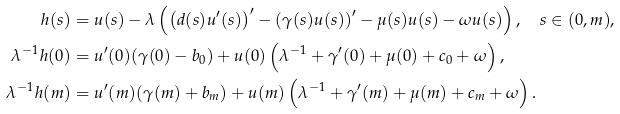Convert formula to latex. <formula><loc_0><loc_0><loc_500><loc_500>h ( s ) & = u ( s ) - \lambda \left ( \left ( d ( s ) u ^ { \prime } ( s ) \right ) ^ { \prime } - \left ( \gamma ( s ) u ( s ) \right ) ^ { \prime } - \mu ( s ) u ( s ) - \omega u ( s ) \right ) , \quad s \in ( 0 , m ) , \\ \lambda ^ { - 1 } h ( 0 ) & = u ^ { \prime } ( 0 ) ( \gamma ( 0 ) - b _ { 0 } ) + u ( 0 ) \left ( \lambda ^ { - 1 } + \gamma ^ { \prime } ( 0 ) + \mu ( 0 ) + c _ { 0 } + \omega \right ) , \\ \lambda ^ { - 1 } h ( m ) & = u ^ { \prime } ( m ) ( \gamma ( m ) + b _ { m } ) + u ( m ) \left ( \lambda ^ { - 1 } + \gamma ^ { \prime } ( m ) + \mu ( m ) + c _ { m } + \omega \right ) .</formula> 